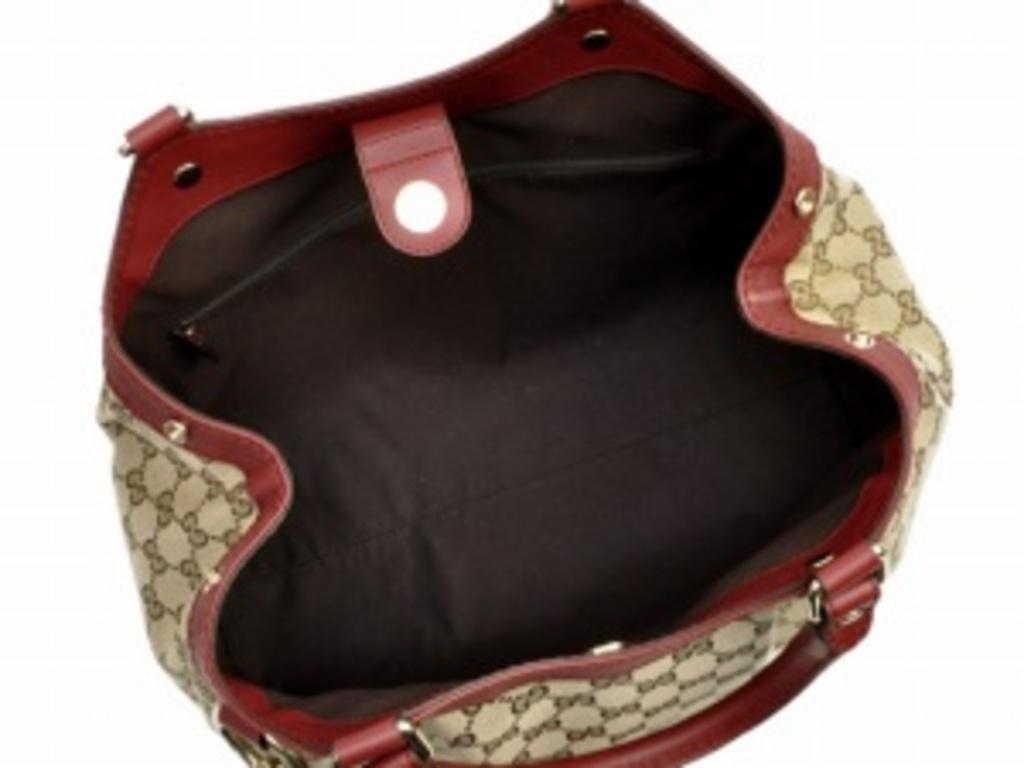Please provide a concise description of this image. In this picture we can see a bag which is opened and to this bag we have some screws, handler. 